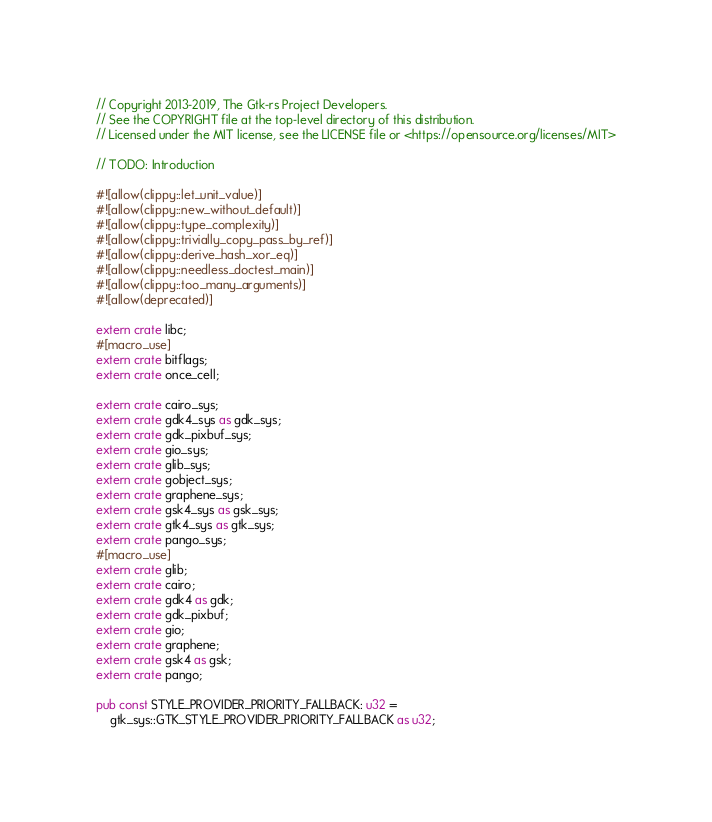<code> <loc_0><loc_0><loc_500><loc_500><_Rust_>// Copyright 2013-2019, The Gtk-rs Project Developers.
// See the COPYRIGHT file at the top-level directory of this distribution.
// Licensed under the MIT license, see the LICENSE file or <https://opensource.org/licenses/MIT>

// TODO: Introduction

#![allow(clippy::let_unit_value)]
#![allow(clippy::new_without_default)]
#![allow(clippy::type_complexity)]
#![allow(clippy::trivially_copy_pass_by_ref)]
#![allow(clippy::derive_hash_xor_eq)]
#![allow(clippy::needless_doctest_main)]
#![allow(clippy::too_many_arguments)]
#![allow(deprecated)]

extern crate libc;
#[macro_use]
extern crate bitflags;
extern crate once_cell;

extern crate cairo_sys;
extern crate gdk4_sys as gdk_sys;
extern crate gdk_pixbuf_sys;
extern crate gio_sys;
extern crate glib_sys;
extern crate gobject_sys;
extern crate graphene_sys;
extern crate gsk4_sys as gsk_sys;
extern crate gtk4_sys as gtk_sys;
extern crate pango_sys;
#[macro_use]
extern crate glib;
extern crate cairo;
extern crate gdk4 as gdk;
extern crate gdk_pixbuf;
extern crate gio;
extern crate graphene;
extern crate gsk4 as gsk;
extern crate pango;

pub const STYLE_PROVIDER_PRIORITY_FALLBACK: u32 =
    gtk_sys::GTK_STYLE_PROVIDER_PRIORITY_FALLBACK as u32;</code> 